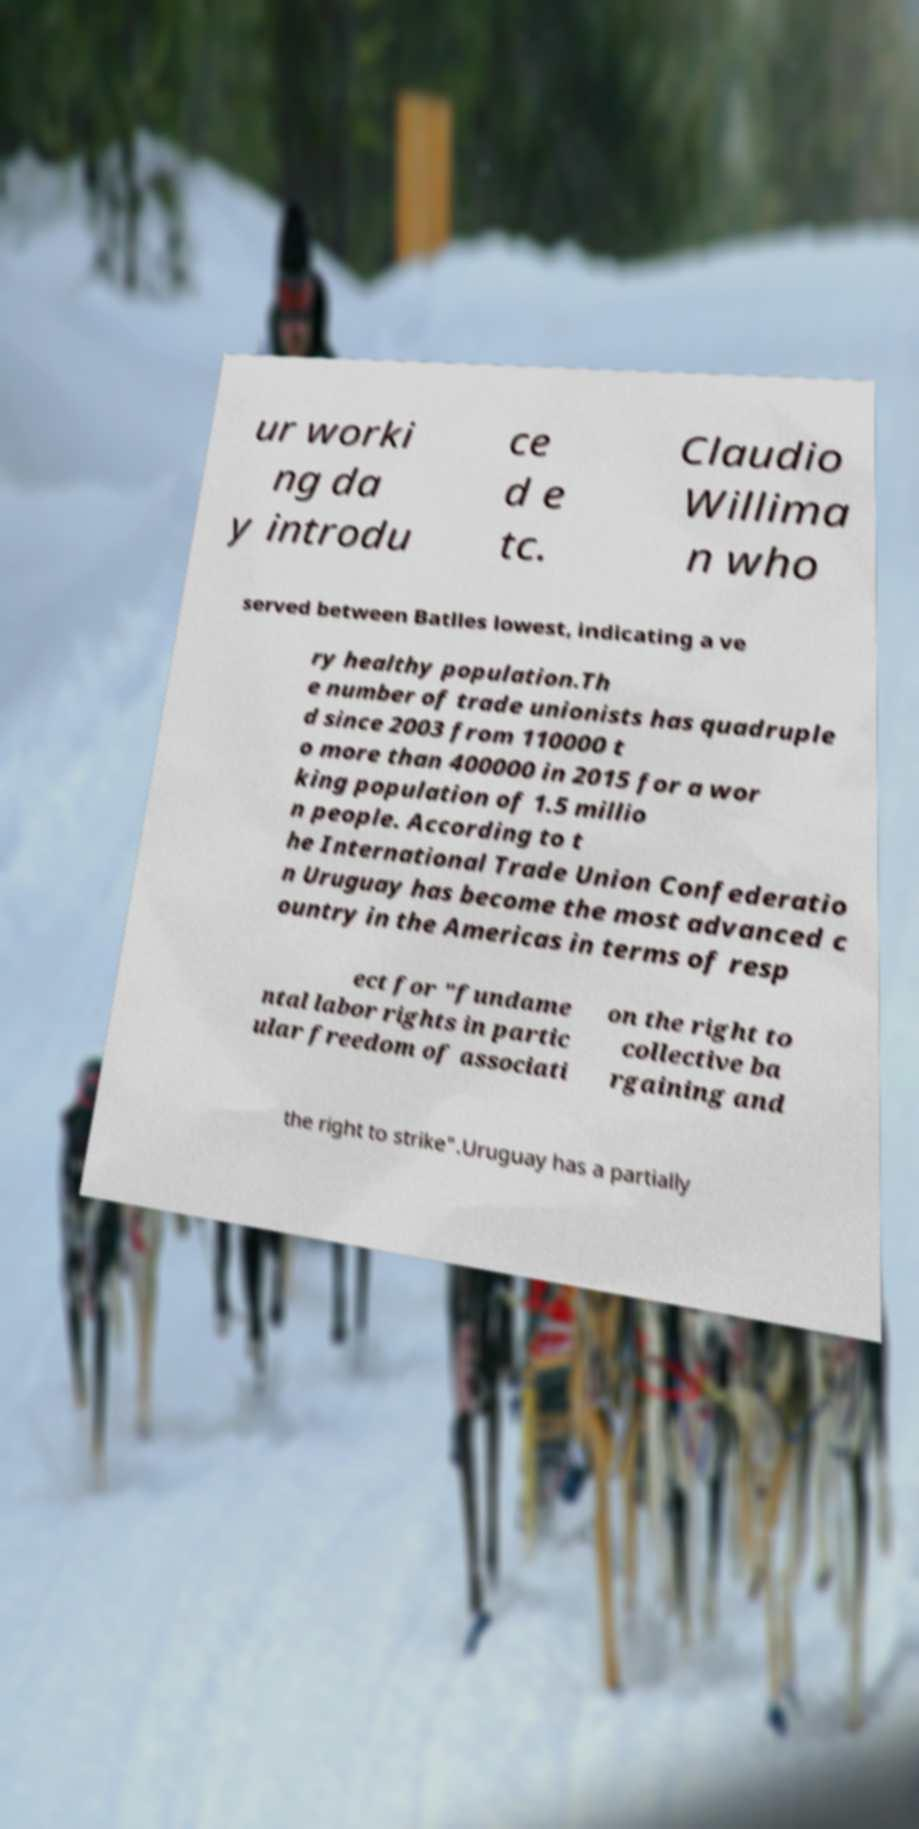I need the written content from this picture converted into text. Can you do that? ur worki ng da y introdu ce d e tc. Claudio Willima n who served between Batlles lowest, indicating a ve ry healthy population.Th e number of trade unionists has quadruple d since 2003 from 110000 t o more than 400000 in 2015 for a wor king population of 1.5 millio n people. According to t he International Trade Union Confederatio n Uruguay has become the most advanced c ountry in the Americas in terms of resp ect for "fundame ntal labor rights in partic ular freedom of associati on the right to collective ba rgaining and the right to strike".Uruguay has a partially 